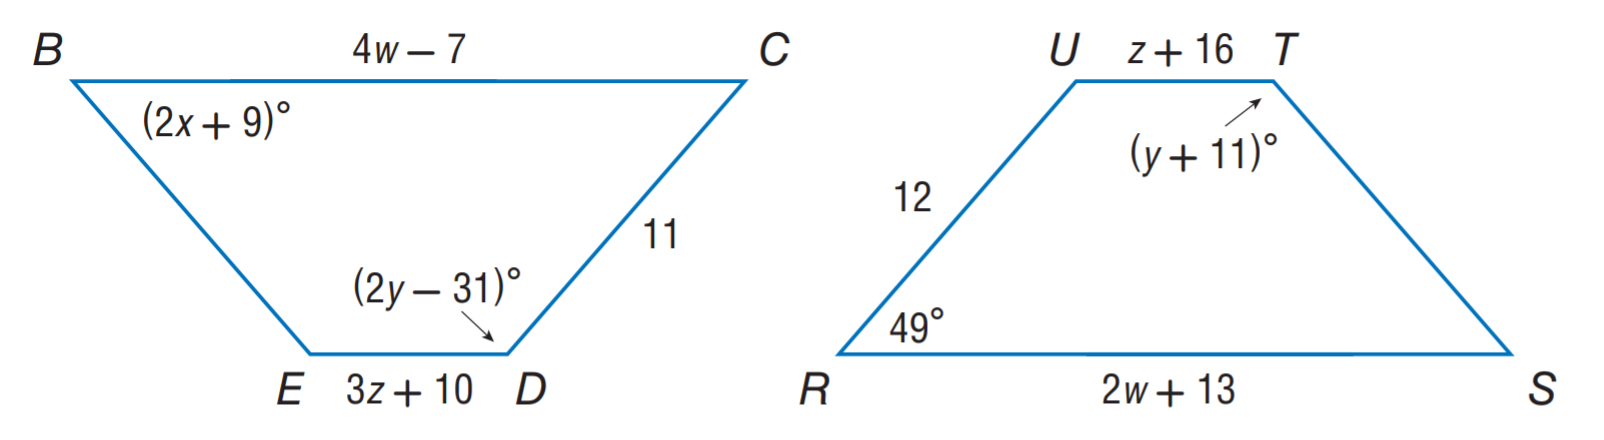Answer the mathemtical geometry problem and directly provide the correct option letter.
Question: Polygon B C D E \cong polygon R S T U. Find x.
Choices: A: 3 B: 10 C: 20 D: 42 C 